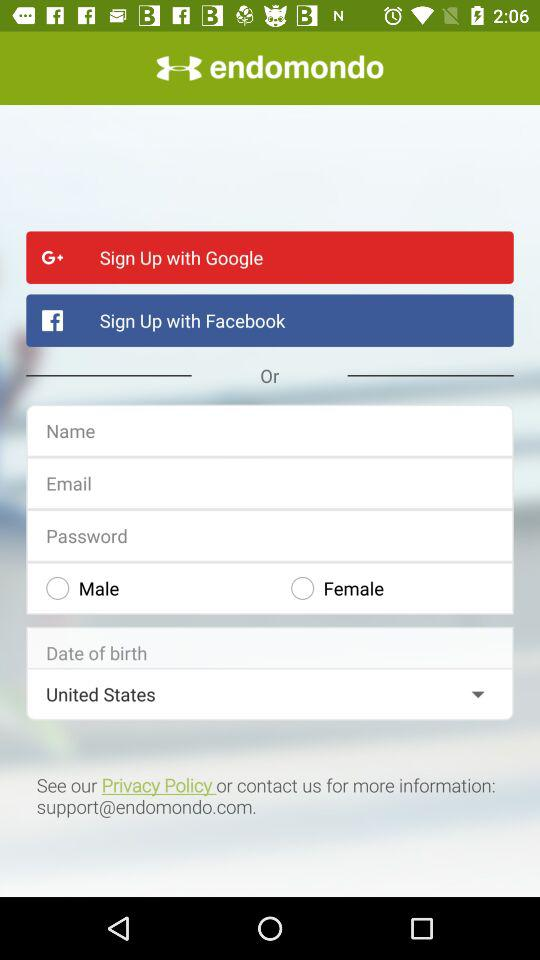What accounts can I use to sign up? You can use "Google", "Facebook" and "Email" accounts to sign up. 